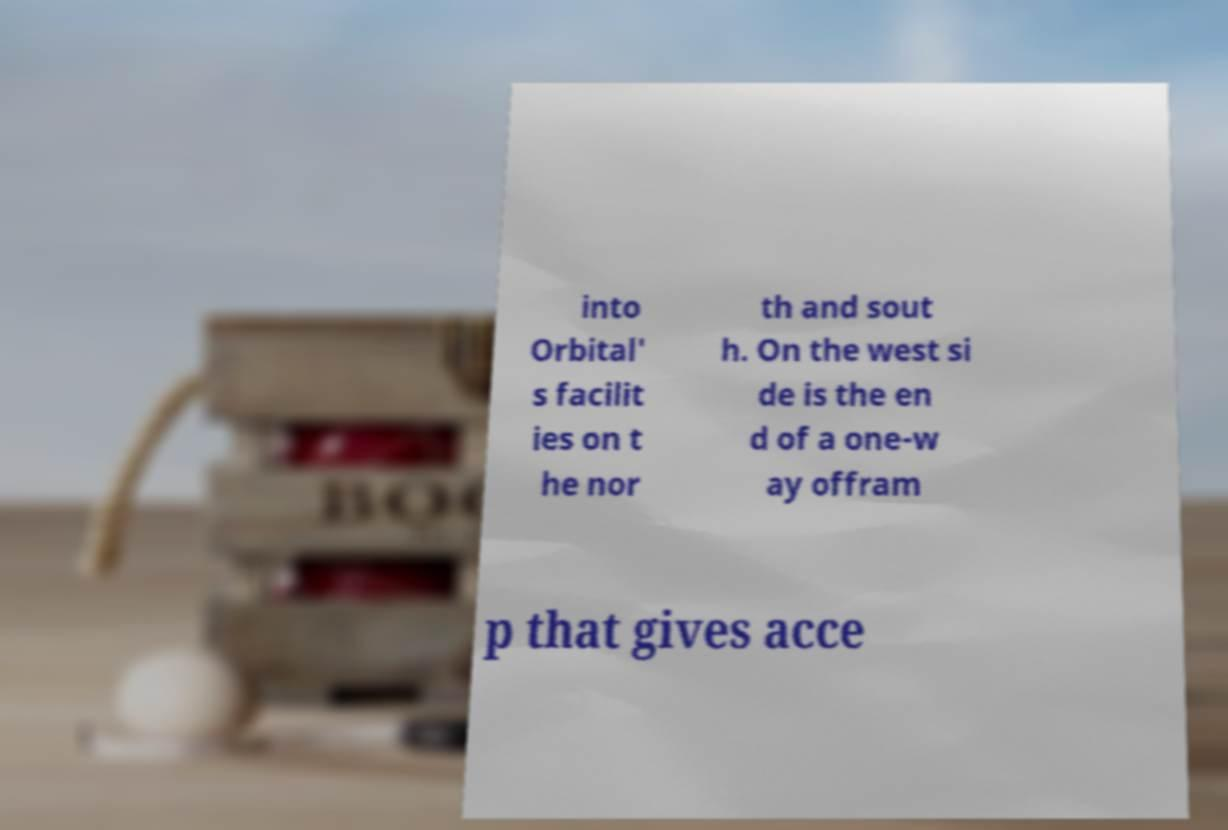Please identify and transcribe the text found in this image. into Orbital' s facilit ies on t he nor th and sout h. On the west si de is the en d of a one-w ay offram p that gives acce 